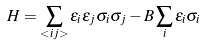<formula> <loc_0><loc_0><loc_500><loc_500>H = \sum _ { < i j > } \epsilon _ { i } \epsilon _ { j } \sigma _ { i } \sigma _ { j } - B \sum _ { i } \epsilon _ { i } \sigma _ { i }</formula> 